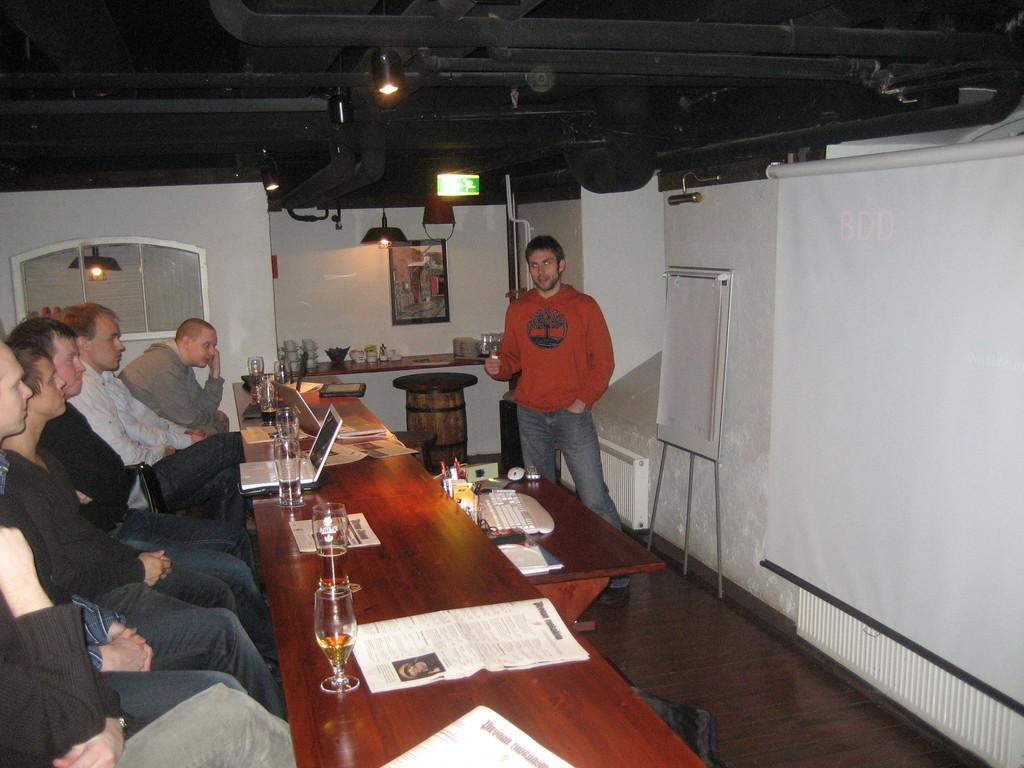In one or two sentences, can you explain what this image depicts? in this picture we can see a group of men sitting on chairs and in front of them on table we have glasses with drink in it, paper, laptop, keyboard, mouse, remote, book and aside to this table we have a person standing and in the background we can see wall, screen, board, frames, light. 